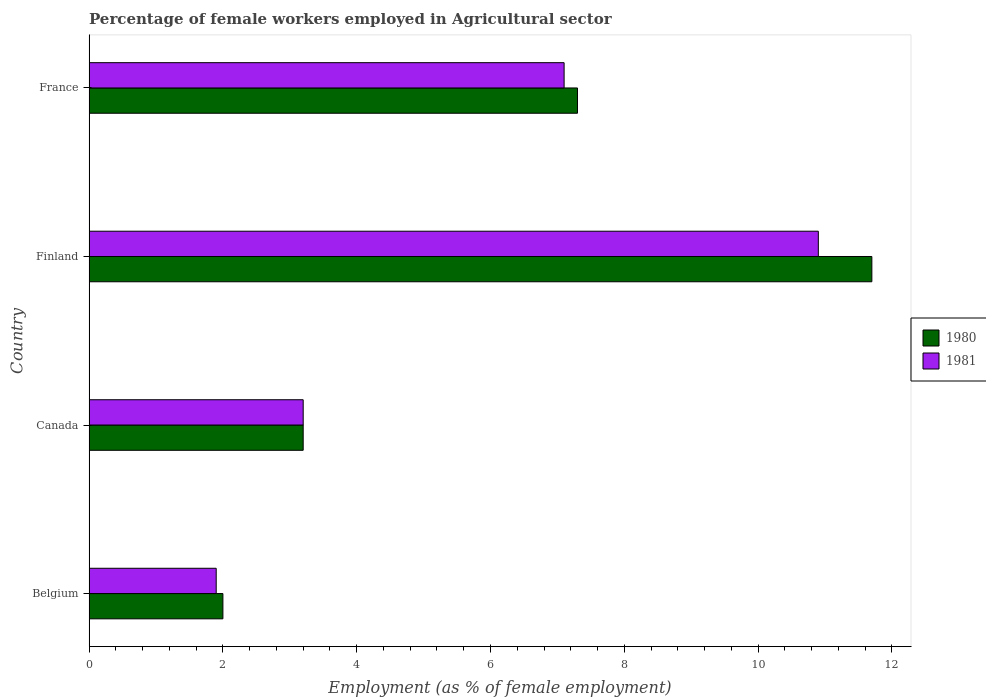Are the number of bars on each tick of the Y-axis equal?
Your answer should be very brief. Yes. How many bars are there on the 3rd tick from the bottom?
Give a very brief answer. 2. What is the label of the 4th group of bars from the top?
Offer a very short reply. Belgium. What is the percentage of females employed in Agricultural sector in 1980 in Canada?
Your answer should be very brief. 3.2. Across all countries, what is the maximum percentage of females employed in Agricultural sector in 1981?
Make the answer very short. 10.9. Across all countries, what is the minimum percentage of females employed in Agricultural sector in 1981?
Provide a succinct answer. 1.9. In which country was the percentage of females employed in Agricultural sector in 1981 maximum?
Your response must be concise. Finland. What is the total percentage of females employed in Agricultural sector in 1980 in the graph?
Provide a short and direct response. 24.2. What is the difference between the percentage of females employed in Agricultural sector in 1981 in Belgium and that in Canada?
Keep it short and to the point. -1.3. What is the difference between the percentage of females employed in Agricultural sector in 1980 in Finland and the percentage of females employed in Agricultural sector in 1981 in Canada?
Your answer should be compact. 8.5. What is the average percentage of females employed in Agricultural sector in 1981 per country?
Offer a very short reply. 5.77. What is the difference between the percentage of females employed in Agricultural sector in 1980 and percentage of females employed in Agricultural sector in 1981 in France?
Keep it short and to the point. 0.2. In how many countries, is the percentage of females employed in Agricultural sector in 1980 greater than 5.2 %?
Ensure brevity in your answer.  2. What is the ratio of the percentage of females employed in Agricultural sector in 1981 in Belgium to that in Canada?
Your answer should be very brief. 0.59. Is the difference between the percentage of females employed in Agricultural sector in 1980 in Canada and France greater than the difference between the percentage of females employed in Agricultural sector in 1981 in Canada and France?
Your answer should be compact. No. What is the difference between the highest and the second highest percentage of females employed in Agricultural sector in 1981?
Offer a terse response. 3.8. What is the difference between the highest and the lowest percentage of females employed in Agricultural sector in 1981?
Your response must be concise. 9. In how many countries, is the percentage of females employed in Agricultural sector in 1981 greater than the average percentage of females employed in Agricultural sector in 1981 taken over all countries?
Make the answer very short. 2. Is the sum of the percentage of females employed in Agricultural sector in 1981 in Belgium and Finland greater than the maximum percentage of females employed in Agricultural sector in 1980 across all countries?
Provide a succinct answer. Yes. What does the 2nd bar from the bottom in Canada represents?
Offer a terse response. 1981. How many bars are there?
Your answer should be very brief. 8. Are all the bars in the graph horizontal?
Your answer should be compact. Yes. What is the difference between two consecutive major ticks on the X-axis?
Offer a terse response. 2. Are the values on the major ticks of X-axis written in scientific E-notation?
Offer a very short reply. No. Does the graph contain any zero values?
Give a very brief answer. No. Does the graph contain grids?
Offer a very short reply. No. Where does the legend appear in the graph?
Keep it short and to the point. Center right. What is the title of the graph?
Keep it short and to the point. Percentage of female workers employed in Agricultural sector. Does "1999" appear as one of the legend labels in the graph?
Your answer should be very brief. No. What is the label or title of the X-axis?
Ensure brevity in your answer.  Employment (as % of female employment). What is the Employment (as % of female employment) of 1981 in Belgium?
Give a very brief answer. 1.9. What is the Employment (as % of female employment) in 1980 in Canada?
Offer a very short reply. 3.2. What is the Employment (as % of female employment) of 1981 in Canada?
Your answer should be compact. 3.2. What is the Employment (as % of female employment) of 1980 in Finland?
Provide a succinct answer. 11.7. What is the Employment (as % of female employment) in 1981 in Finland?
Give a very brief answer. 10.9. What is the Employment (as % of female employment) of 1980 in France?
Your answer should be very brief. 7.3. What is the Employment (as % of female employment) in 1981 in France?
Make the answer very short. 7.1. Across all countries, what is the maximum Employment (as % of female employment) in 1980?
Your answer should be compact. 11.7. Across all countries, what is the maximum Employment (as % of female employment) of 1981?
Your response must be concise. 10.9. Across all countries, what is the minimum Employment (as % of female employment) in 1981?
Offer a very short reply. 1.9. What is the total Employment (as % of female employment) of 1980 in the graph?
Give a very brief answer. 24.2. What is the total Employment (as % of female employment) of 1981 in the graph?
Give a very brief answer. 23.1. What is the difference between the Employment (as % of female employment) of 1980 in Belgium and that in Canada?
Make the answer very short. -1.2. What is the difference between the Employment (as % of female employment) of 1980 in Belgium and that in Finland?
Keep it short and to the point. -9.7. What is the difference between the Employment (as % of female employment) in 1981 in Belgium and that in Finland?
Offer a very short reply. -9. What is the difference between the Employment (as % of female employment) in 1981 in Belgium and that in France?
Your answer should be compact. -5.2. What is the difference between the Employment (as % of female employment) in 1980 in Canada and that in Finland?
Offer a very short reply. -8.5. What is the difference between the Employment (as % of female employment) of 1981 in Canada and that in Finland?
Ensure brevity in your answer.  -7.7. What is the difference between the Employment (as % of female employment) in 1980 in Finland and that in France?
Offer a very short reply. 4.4. What is the difference between the Employment (as % of female employment) of 1980 in Belgium and the Employment (as % of female employment) of 1981 in Canada?
Give a very brief answer. -1.2. What is the difference between the Employment (as % of female employment) of 1980 in Belgium and the Employment (as % of female employment) of 1981 in Finland?
Offer a terse response. -8.9. What is the difference between the Employment (as % of female employment) in 1980 in Belgium and the Employment (as % of female employment) in 1981 in France?
Your answer should be very brief. -5.1. What is the difference between the Employment (as % of female employment) in 1980 in Finland and the Employment (as % of female employment) in 1981 in France?
Give a very brief answer. 4.6. What is the average Employment (as % of female employment) of 1980 per country?
Your answer should be compact. 6.05. What is the average Employment (as % of female employment) of 1981 per country?
Give a very brief answer. 5.78. What is the difference between the Employment (as % of female employment) in 1980 and Employment (as % of female employment) in 1981 in Belgium?
Make the answer very short. 0.1. What is the difference between the Employment (as % of female employment) in 1980 and Employment (as % of female employment) in 1981 in Canada?
Offer a very short reply. 0. What is the difference between the Employment (as % of female employment) of 1980 and Employment (as % of female employment) of 1981 in Finland?
Provide a short and direct response. 0.8. What is the ratio of the Employment (as % of female employment) in 1980 in Belgium to that in Canada?
Provide a succinct answer. 0.62. What is the ratio of the Employment (as % of female employment) of 1981 in Belgium to that in Canada?
Offer a terse response. 0.59. What is the ratio of the Employment (as % of female employment) in 1980 in Belgium to that in Finland?
Offer a very short reply. 0.17. What is the ratio of the Employment (as % of female employment) in 1981 in Belgium to that in Finland?
Make the answer very short. 0.17. What is the ratio of the Employment (as % of female employment) in 1980 in Belgium to that in France?
Provide a succinct answer. 0.27. What is the ratio of the Employment (as % of female employment) of 1981 in Belgium to that in France?
Your answer should be compact. 0.27. What is the ratio of the Employment (as % of female employment) in 1980 in Canada to that in Finland?
Your answer should be very brief. 0.27. What is the ratio of the Employment (as % of female employment) in 1981 in Canada to that in Finland?
Your answer should be very brief. 0.29. What is the ratio of the Employment (as % of female employment) of 1980 in Canada to that in France?
Provide a short and direct response. 0.44. What is the ratio of the Employment (as % of female employment) in 1981 in Canada to that in France?
Give a very brief answer. 0.45. What is the ratio of the Employment (as % of female employment) in 1980 in Finland to that in France?
Ensure brevity in your answer.  1.6. What is the ratio of the Employment (as % of female employment) in 1981 in Finland to that in France?
Ensure brevity in your answer.  1.54. What is the difference between the highest and the second highest Employment (as % of female employment) in 1981?
Provide a succinct answer. 3.8. What is the difference between the highest and the lowest Employment (as % of female employment) in 1981?
Provide a succinct answer. 9. 